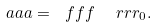Convert formula to latex. <formula><loc_0><loc_0><loc_500><loc_500>\ a a a = \ f f f \ \ r r r _ { 0 } .</formula> 